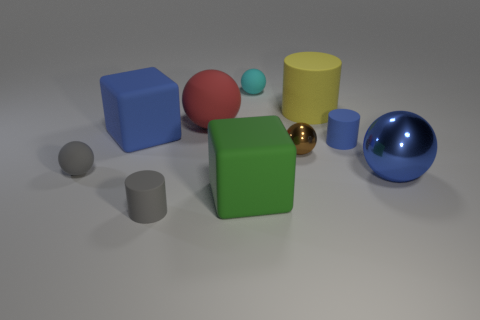Subtract 2 balls. How many balls are left? 3 Subtract all gray balls. How many balls are left? 4 Subtract all gray rubber spheres. How many spheres are left? 4 Subtract all green spheres. Subtract all gray blocks. How many spheres are left? 5 Subtract all blocks. How many objects are left? 8 Add 10 tiny purple metal cylinders. How many tiny purple metal cylinders exist? 10 Subtract 0 purple spheres. How many objects are left? 10 Subtract all brown rubber things. Subtract all big shiny objects. How many objects are left? 9 Add 7 green things. How many green things are left? 8 